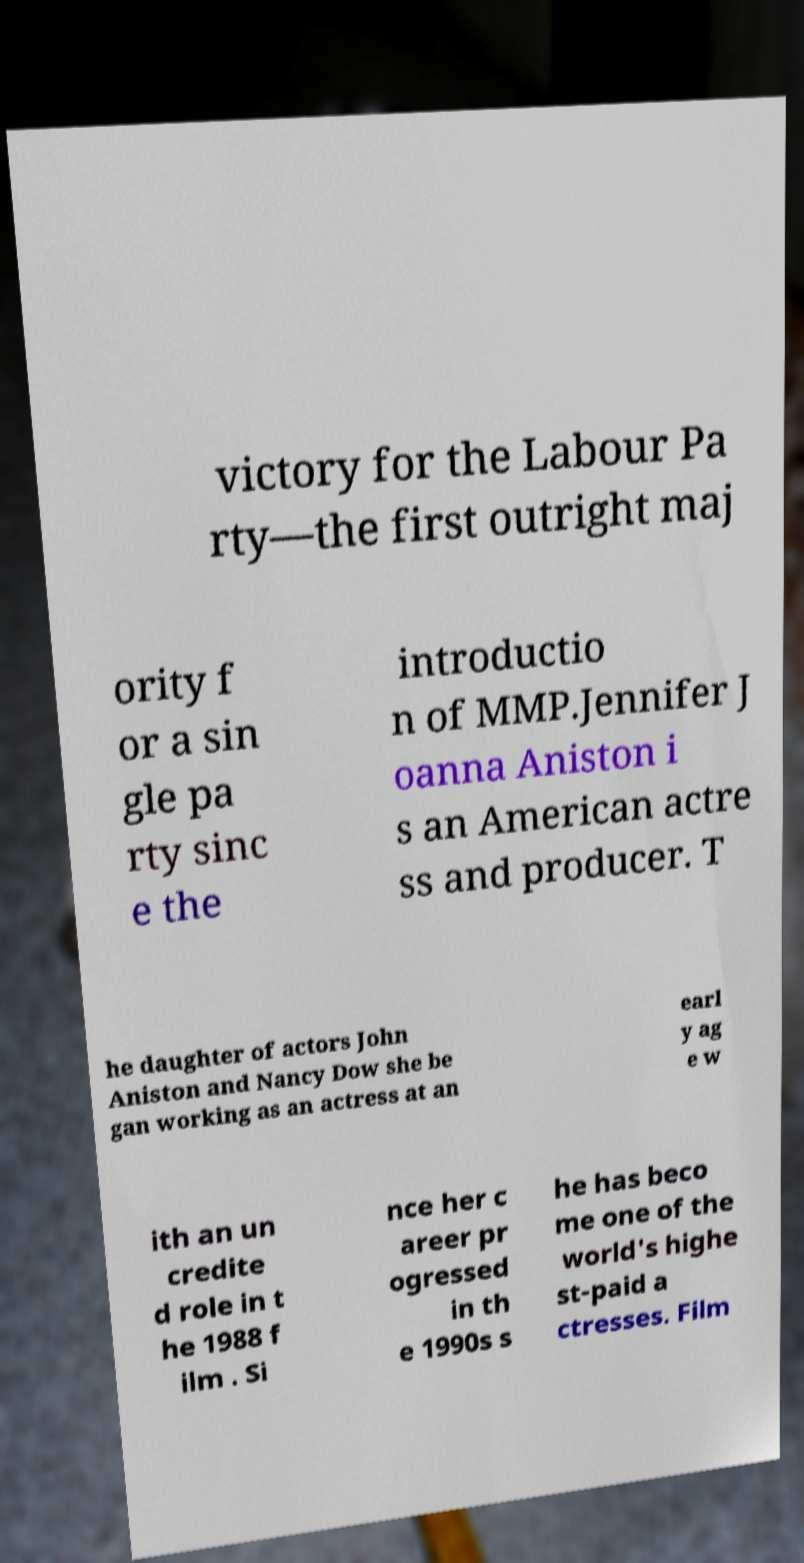Can you accurately transcribe the text from the provided image for me? victory for the Labour Pa rty—the first outright maj ority f or a sin gle pa rty sinc e the introductio n of MMP.Jennifer J oanna Aniston i s an American actre ss and producer. T he daughter of actors John Aniston and Nancy Dow she be gan working as an actress at an earl y ag e w ith an un credite d role in t he 1988 f ilm . Si nce her c areer pr ogressed in th e 1990s s he has beco me one of the world's highe st-paid a ctresses. Film 